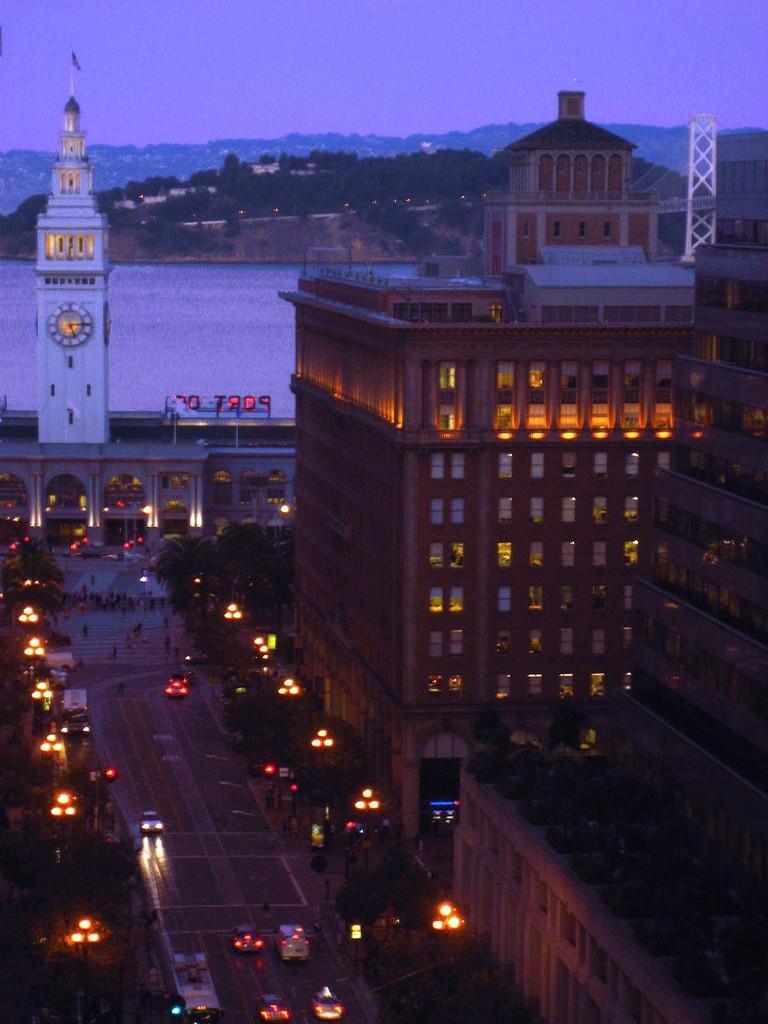In one or two sentences, can you explain what this image depicts? In this image we can see vehicles on the road. Right side of the image, buildings are present. In the background, we can see water body, tower, trees and building. At the top of the image, we can see the sky. 